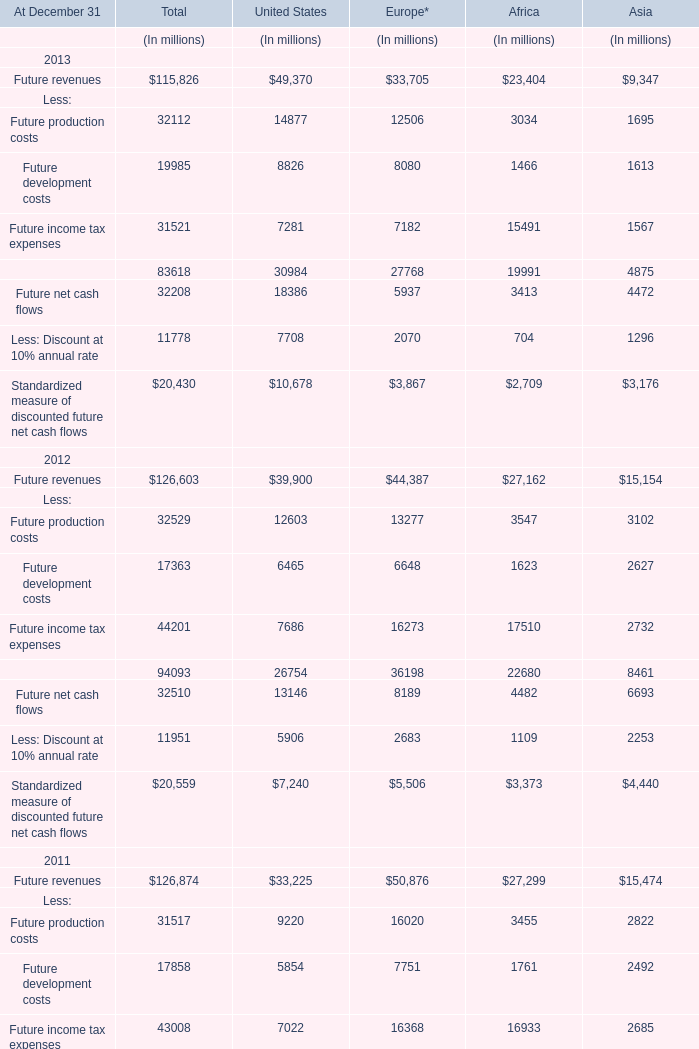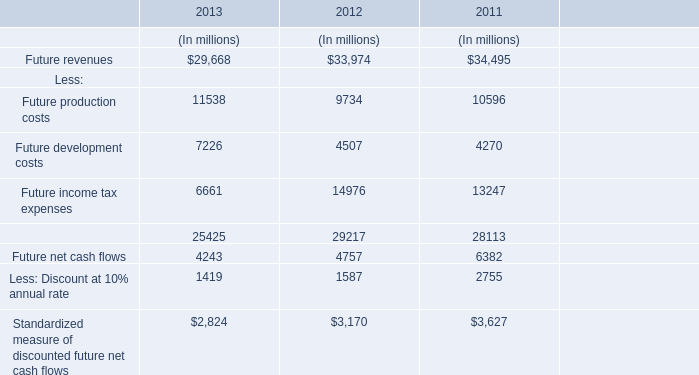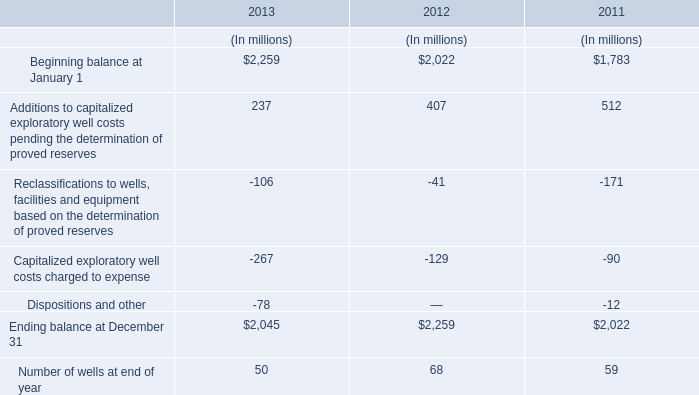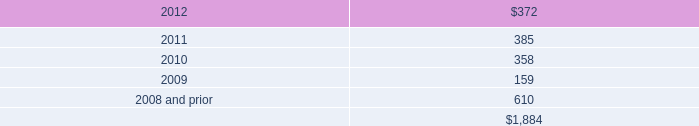How many element exceed the average of Future revenues in 2013? 
Answer: 2. 